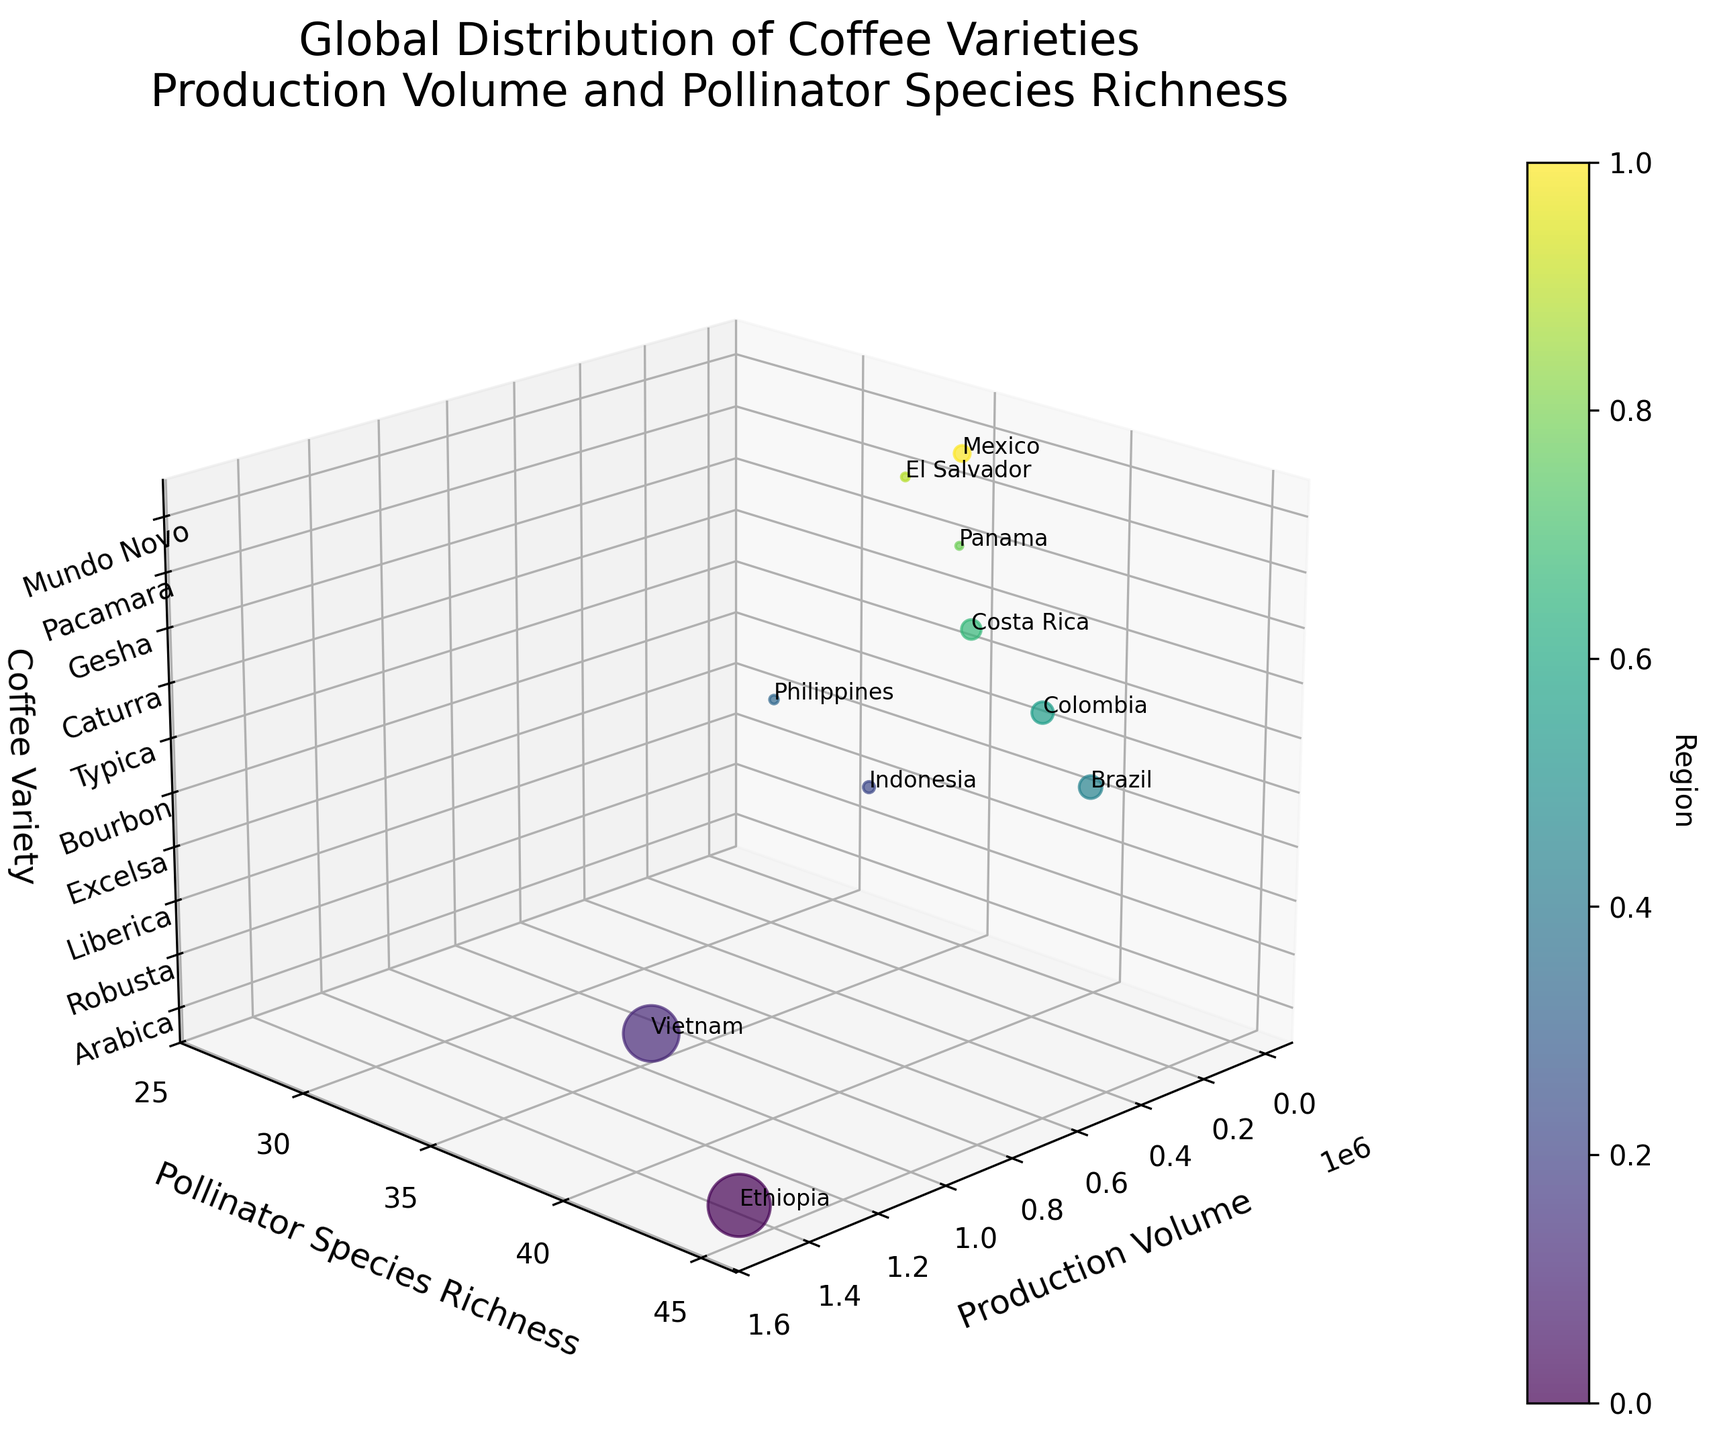What's the title of the figure? The title is usually displayed at the top of the figure in a larger font size. In this case, it reads "Global Distribution of Coffee Varieties\nProduction Volume and Pollinator Species Richness".
Answer: Global Distribution of Coffee Varieties\nProduction Volume and Pollinator Species Richness How many different coffee varieties are represented in the figure? The z-axis represents coffee varieties, and each tick corresponds to one variety. Counting the ticks or labels provides the answer.
Answer: 10 Which region has the highest pollinator species richness? The y-axis represents pollinator species richness. By identifying the highest point on this axis and checking the corresponding label, we find the answer.
Answer: Ethiopia What is the production volume for Robusta coffee? The x-axis represents production volume. By locating Robusta on the z-axis and tracing its corresponding point on the x-axis, we can determine the production volume.
Answer: 1,200,000 Which coffee variety has the lowest production volume? The x-axis represents production volume. By identifying the smallest value on this axis and checking the corresponding label on the z-axis, we find the answer.
Answer: Gesha How does the pollinator species richness of Arabica and Robusta compare? Look at the y-axis for the values corresponding to Arabica and Robusta on the z-axis. Compare the numbers to see which is higher.
Answer: Arabica has more pollinator species richness than Robusta What is the average pollinator species richness across all coffee varieties? Sum the pollinator species richness values for all coffee varieties and then divide by the number of varieties (10). Calculation: (45 + 38 + 32 + 28 + 42 + 40 + 37 + 35 + 33 + 36) / 10 = 36.6
Answer: 36.6 Which coffee variety from Colombia and Costa Rica: Which has a higher production volume? Identify the coffee varieties from Colombia (Typica) and Costa Rica (Caturra) and compare their production volumes on the x-axis.
Answer: Typica What is the relationship between production volume and pollinator species richness for Brazil’s Bourbon? Locate Bourbon on the z-axis and trace its corresponding production volume on the x-axis and pollinator species richness on the y-axis to see the relationship.
Answer: High production volume, high pollinator species richness How does the region color bar relate to the data points? The color bar on the side correlates regions to colors. Each point's color matches the region it represents, making it easy to identify regions visually.
Answer: Color-coded by region 